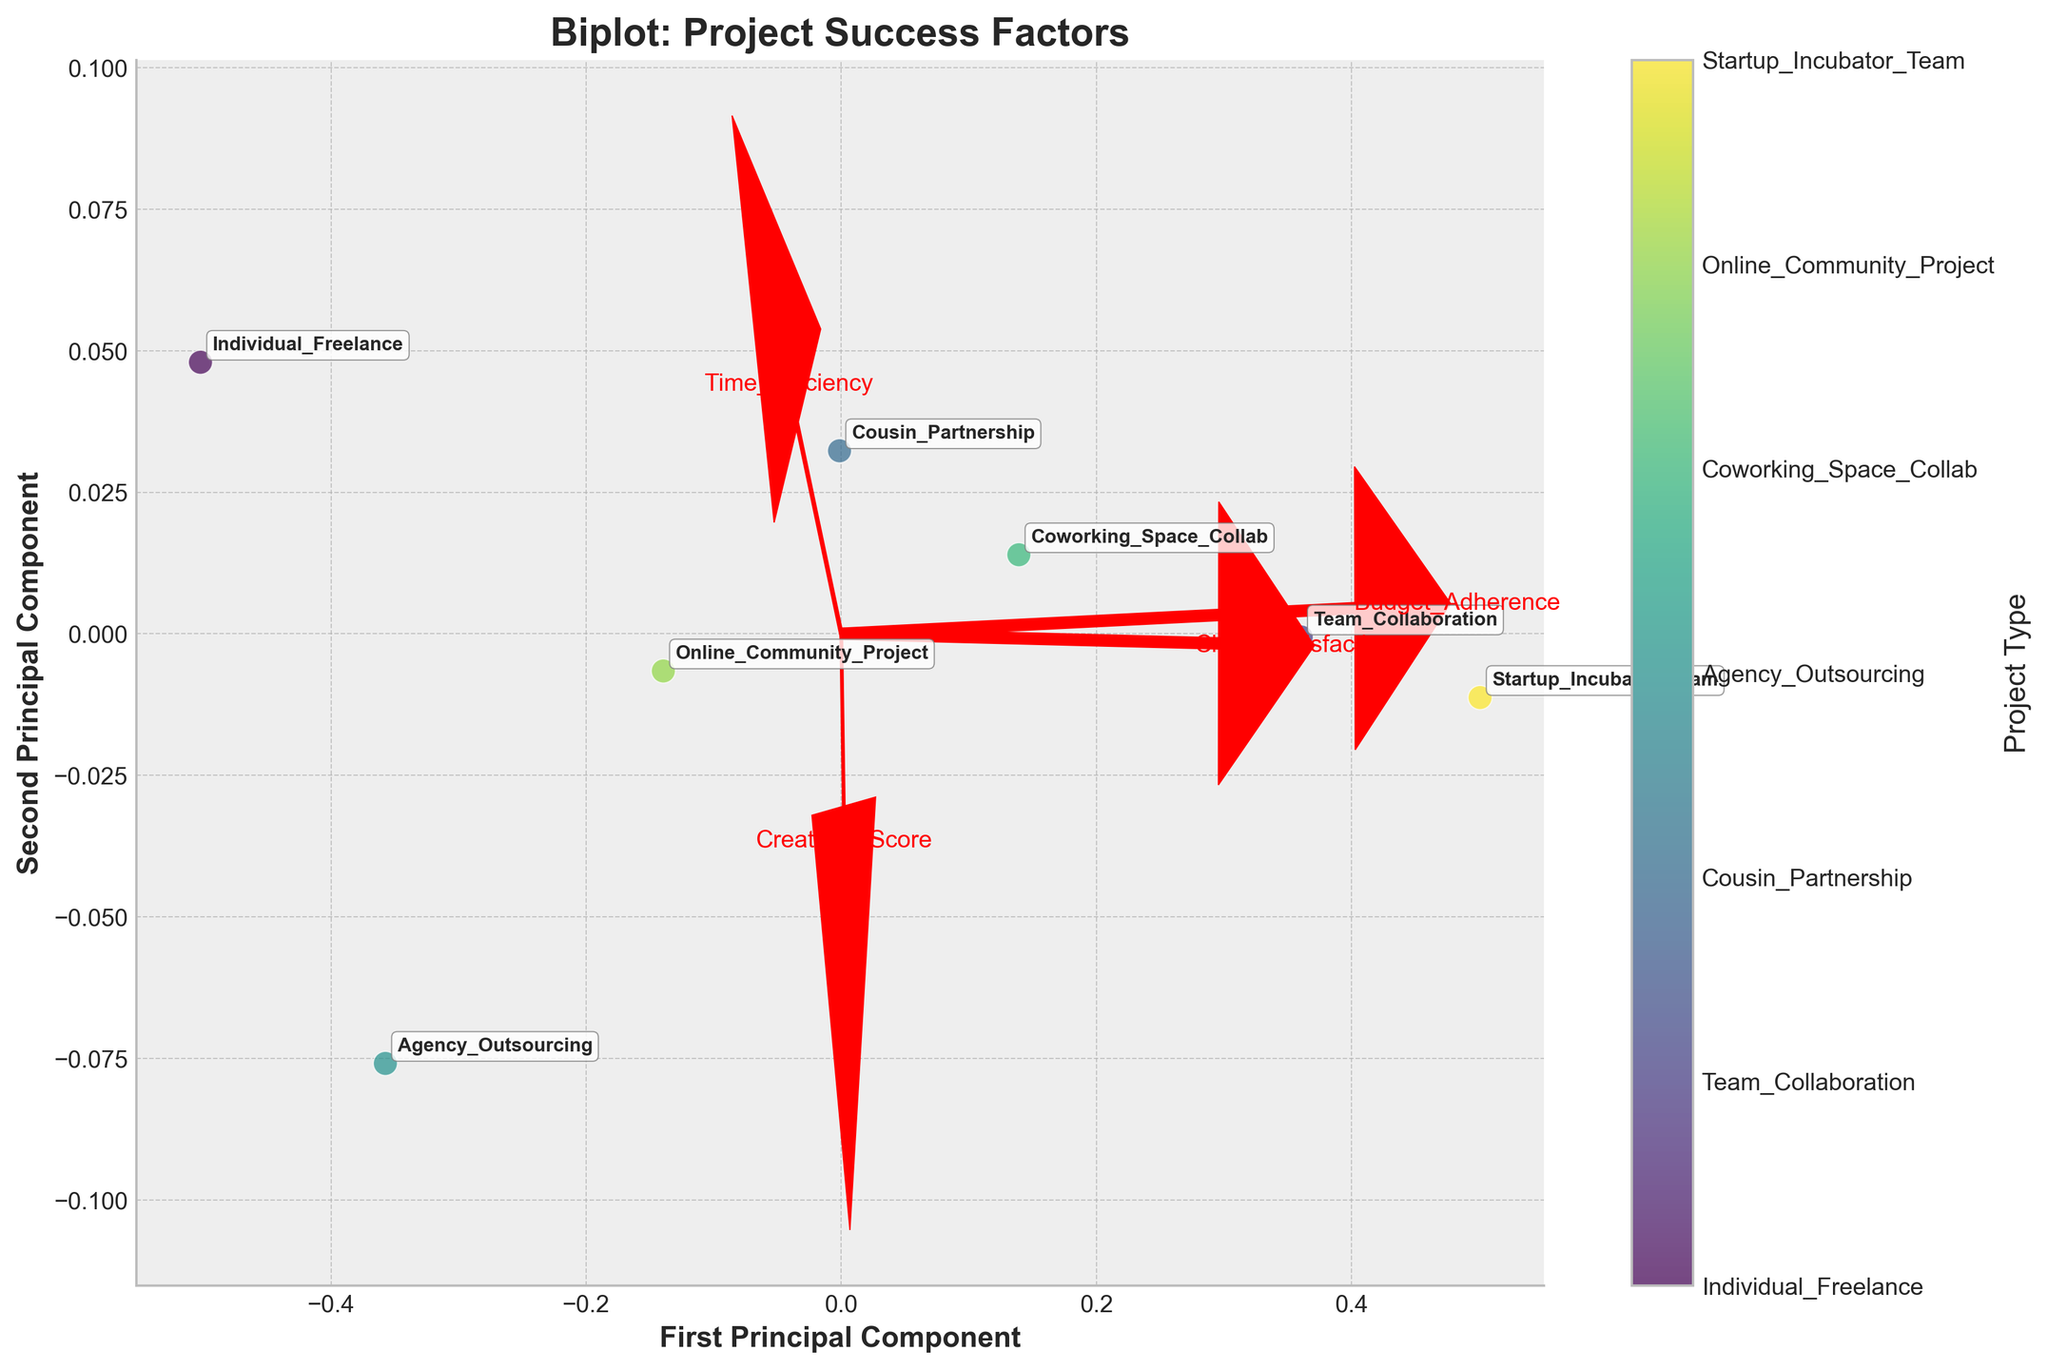What's the title of the plot? The title of the plot is prominently displayed at the top of the figure, above the graph area, where it usually states the purpose or the key theme of the plot.
Answer: Biplot: Project Success Factors How many project types are represented in the figure? The number of project types can be determined by counting the unique labels associated with each data point in the scatter plot.
Answer: 7 Which type of project has the highest First Principal Component score? To identify the project type with the highest First Principal Component score, locate the data point with the furthest position along the x-axis.
Answer: Startup Incubator Team What is the color scheme used for differentiating project types? The color scheme used for differentiating project types can be identified by examining the different colors in the scatter plot and their corresponding project types in the color bar.
Answer: Viridis How does "Team Collaboration" compare to "Individual Freelance" in terms of the Second Principal Component? Compare the positions of "Team Collaboration" and "Individual Freelance" on the y-axis to determine which has a higher Second Principal Component value.
Answer: Team Collaboration has a slightly lower Second Principal Component score Which feature vector has the steepest angle, indicating the most influence on the First Principal Component? By examining the angles of the red arrows (feature vectors) relative to the x-axis, the steepest arrow indicates the feature with the most influence on the First Principal Component.
Answer: Client Satisfaction Is "Cousin Partnership" closer to "Individual Freelance" or "Online Community Project" in the biplot? Find the data points labeled "Cousin Partnership," "Individual Freelance," and "Online Community Project," and compare their distances to determine proximity.
Answer: Closer to Online Community Project What are the coordinates of the arrow representing the "Creativity Score"? The coordinates of the arrows can be read from their endpoints, indicating the direction and magnitude of each feature vector in relation to the axes.
Answer: (1.2 * Vt[4, 0] * max(PC[:, 0]), 1.2 * Vt[4, 1] * max(PC[:, 1])) What does the length of the arrows represent in the biplot? The length of the arrows in the biplot represents the significance or influence of each feature on the principal components. Longer arrows indicate higher influence.
Answer: Significance of features Does "Agency Outsourcing" have a higher Success Rate or Client Satisfaction score when compared visually? Compare the positions of the "Agency Outsourcing" data point along the directions indicated by the "Success Rate" and "Client Satisfaction" feature vectors.
Answer: Client Satisfaction score 